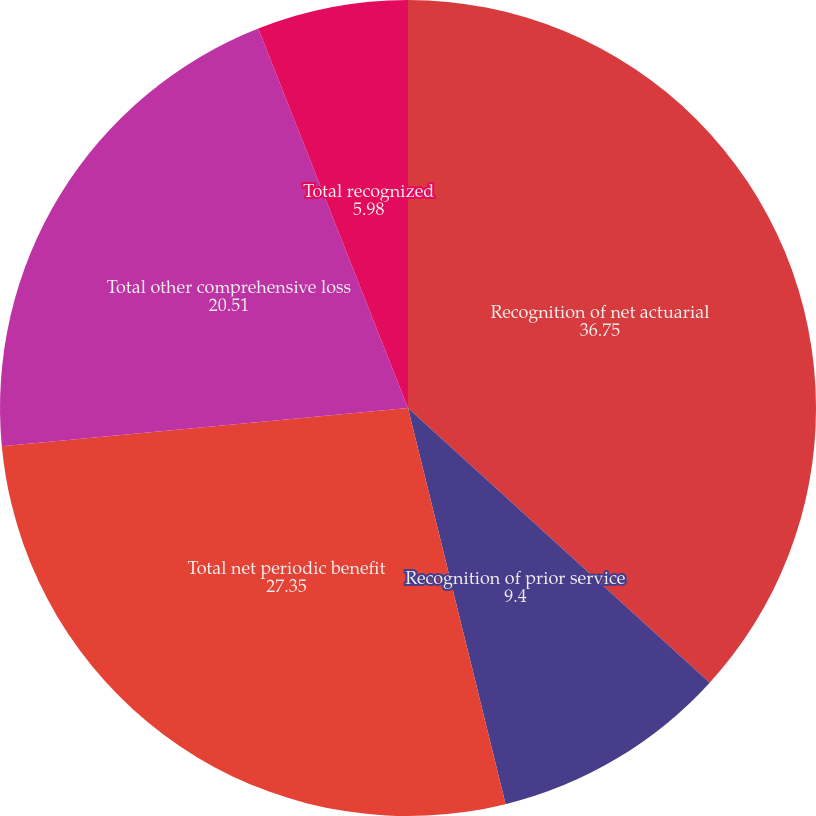Convert chart to OTSL. <chart><loc_0><loc_0><loc_500><loc_500><pie_chart><fcel>Recognition of net actuarial<fcel>Recognition of prior service<fcel>Total net periodic benefit<fcel>Total other comprehensive loss<fcel>Total recognized<nl><fcel>36.75%<fcel>9.4%<fcel>27.35%<fcel>20.51%<fcel>5.98%<nl></chart> 